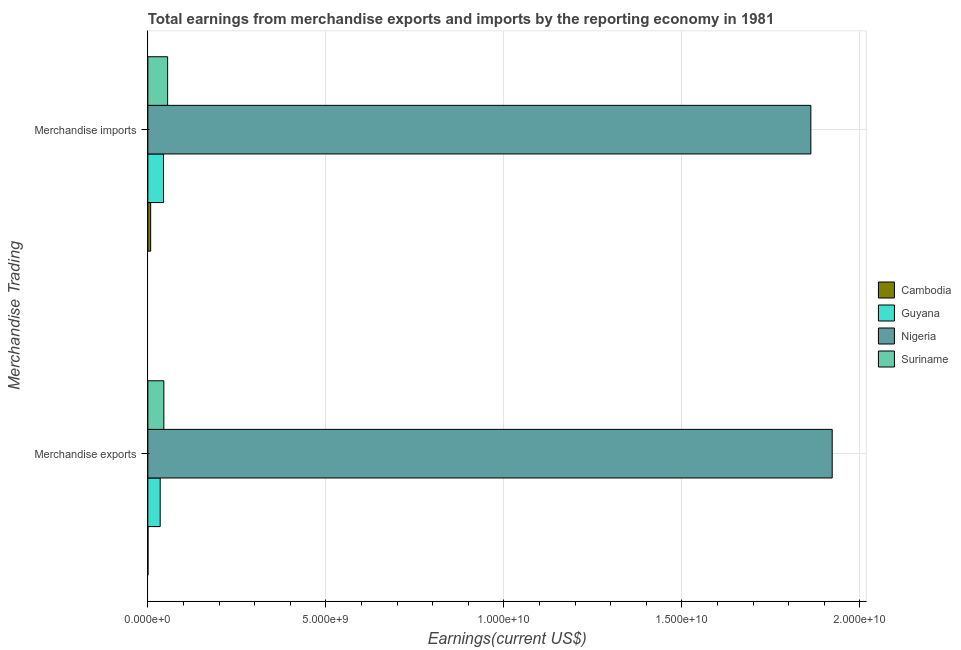How many bars are there on the 1st tick from the top?
Provide a short and direct response. 4. How many bars are there on the 2nd tick from the bottom?
Offer a very short reply. 4. What is the label of the 2nd group of bars from the top?
Offer a very short reply. Merchandise exports. What is the earnings from merchandise imports in Nigeria?
Your answer should be very brief. 1.86e+1. Across all countries, what is the maximum earnings from merchandise exports?
Offer a terse response. 1.92e+1. Across all countries, what is the minimum earnings from merchandise exports?
Keep it short and to the point. 2.37e+06. In which country was the earnings from merchandise exports maximum?
Your response must be concise. Nigeria. In which country was the earnings from merchandise imports minimum?
Offer a terse response. Cambodia. What is the total earnings from merchandise imports in the graph?
Make the answer very short. 1.97e+1. What is the difference between the earnings from merchandise imports in Nigeria and that in Guyana?
Your response must be concise. 1.82e+1. What is the difference between the earnings from merchandise imports in Nigeria and the earnings from merchandise exports in Guyana?
Keep it short and to the point. 1.83e+1. What is the average earnings from merchandise imports per country?
Offer a very short reply. 4.92e+09. What is the difference between the earnings from merchandise exports and earnings from merchandise imports in Nigeria?
Provide a short and direct response. 6.00e+08. In how many countries, is the earnings from merchandise imports greater than 18000000000 US$?
Offer a very short reply. 1. What is the ratio of the earnings from merchandise imports in Nigeria to that in Suriname?
Offer a very short reply. 33.57. In how many countries, is the earnings from merchandise exports greater than the average earnings from merchandise exports taken over all countries?
Make the answer very short. 1. What does the 3rd bar from the top in Merchandise exports represents?
Give a very brief answer. Guyana. What does the 1st bar from the bottom in Merchandise imports represents?
Provide a short and direct response. Cambodia. How many bars are there?
Provide a succinct answer. 8. Are all the bars in the graph horizontal?
Provide a succinct answer. Yes. Does the graph contain any zero values?
Ensure brevity in your answer.  No. How many legend labels are there?
Ensure brevity in your answer.  4. How are the legend labels stacked?
Offer a very short reply. Vertical. What is the title of the graph?
Offer a very short reply. Total earnings from merchandise exports and imports by the reporting economy in 1981. Does "Croatia" appear as one of the legend labels in the graph?
Give a very brief answer. No. What is the label or title of the X-axis?
Offer a terse response. Earnings(current US$). What is the label or title of the Y-axis?
Offer a terse response. Merchandise Trading. What is the Earnings(current US$) in Cambodia in Merchandise exports?
Your answer should be very brief. 2.37e+06. What is the Earnings(current US$) of Guyana in Merchandise exports?
Your answer should be compact. 3.46e+08. What is the Earnings(current US$) in Nigeria in Merchandise exports?
Your answer should be very brief. 1.92e+1. What is the Earnings(current US$) of Suriname in Merchandise exports?
Your response must be concise. 4.49e+08. What is the Earnings(current US$) of Cambodia in Merchandise imports?
Your answer should be very brief. 7.84e+07. What is the Earnings(current US$) in Guyana in Merchandise imports?
Your answer should be very brief. 4.40e+08. What is the Earnings(current US$) in Nigeria in Merchandise imports?
Ensure brevity in your answer.  1.86e+1. What is the Earnings(current US$) in Suriname in Merchandise imports?
Keep it short and to the point. 5.55e+08. Across all Merchandise Trading, what is the maximum Earnings(current US$) of Cambodia?
Provide a short and direct response. 7.84e+07. Across all Merchandise Trading, what is the maximum Earnings(current US$) in Guyana?
Your answer should be very brief. 4.40e+08. Across all Merchandise Trading, what is the maximum Earnings(current US$) of Nigeria?
Your answer should be very brief. 1.92e+1. Across all Merchandise Trading, what is the maximum Earnings(current US$) of Suriname?
Provide a short and direct response. 5.55e+08. Across all Merchandise Trading, what is the minimum Earnings(current US$) in Cambodia?
Your answer should be compact. 2.37e+06. Across all Merchandise Trading, what is the minimum Earnings(current US$) of Guyana?
Offer a very short reply. 3.46e+08. Across all Merchandise Trading, what is the minimum Earnings(current US$) in Nigeria?
Make the answer very short. 1.86e+1. Across all Merchandise Trading, what is the minimum Earnings(current US$) of Suriname?
Give a very brief answer. 4.49e+08. What is the total Earnings(current US$) of Cambodia in the graph?
Your answer should be very brief. 8.07e+07. What is the total Earnings(current US$) in Guyana in the graph?
Provide a succinct answer. 7.86e+08. What is the total Earnings(current US$) in Nigeria in the graph?
Offer a very short reply. 3.78e+1. What is the total Earnings(current US$) in Suriname in the graph?
Keep it short and to the point. 1.00e+09. What is the difference between the Earnings(current US$) of Cambodia in Merchandise exports and that in Merchandise imports?
Your response must be concise. -7.60e+07. What is the difference between the Earnings(current US$) of Guyana in Merchandise exports and that in Merchandise imports?
Your answer should be compact. -9.35e+07. What is the difference between the Earnings(current US$) in Nigeria in Merchandise exports and that in Merchandise imports?
Ensure brevity in your answer.  6.00e+08. What is the difference between the Earnings(current US$) of Suriname in Merchandise exports and that in Merchandise imports?
Provide a succinct answer. -1.05e+08. What is the difference between the Earnings(current US$) of Cambodia in Merchandise exports and the Earnings(current US$) of Guyana in Merchandise imports?
Provide a short and direct response. -4.37e+08. What is the difference between the Earnings(current US$) in Cambodia in Merchandise exports and the Earnings(current US$) in Nigeria in Merchandise imports?
Your answer should be compact. -1.86e+1. What is the difference between the Earnings(current US$) in Cambodia in Merchandise exports and the Earnings(current US$) in Suriname in Merchandise imports?
Your answer should be very brief. -5.52e+08. What is the difference between the Earnings(current US$) in Guyana in Merchandise exports and the Earnings(current US$) in Nigeria in Merchandise imports?
Ensure brevity in your answer.  -1.83e+1. What is the difference between the Earnings(current US$) of Guyana in Merchandise exports and the Earnings(current US$) of Suriname in Merchandise imports?
Your answer should be compact. -2.09e+08. What is the difference between the Earnings(current US$) of Nigeria in Merchandise exports and the Earnings(current US$) of Suriname in Merchandise imports?
Ensure brevity in your answer.  1.87e+1. What is the average Earnings(current US$) in Cambodia per Merchandise Trading?
Offer a terse response. 4.04e+07. What is the average Earnings(current US$) in Guyana per Merchandise Trading?
Your answer should be compact. 3.93e+08. What is the average Earnings(current US$) in Nigeria per Merchandise Trading?
Offer a very short reply. 1.89e+1. What is the average Earnings(current US$) in Suriname per Merchandise Trading?
Your answer should be compact. 5.02e+08. What is the difference between the Earnings(current US$) in Cambodia and Earnings(current US$) in Guyana in Merchandise exports?
Your response must be concise. -3.44e+08. What is the difference between the Earnings(current US$) in Cambodia and Earnings(current US$) in Nigeria in Merchandise exports?
Give a very brief answer. -1.92e+1. What is the difference between the Earnings(current US$) of Cambodia and Earnings(current US$) of Suriname in Merchandise exports?
Your answer should be compact. -4.47e+08. What is the difference between the Earnings(current US$) of Guyana and Earnings(current US$) of Nigeria in Merchandise exports?
Offer a terse response. -1.89e+1. What is the difference between the Earnings(current US$) of Guyana and Earnings(current US$) of Suriname in Merchandise exports?
Keep it short and to the point. -1.03e+08. What is the difference between the Earnings(current US$) of Nigeria and Earnings(current US$) of Suriname in Merchandise exports?
Provide a short and direct response. 1.88e+1. What is the difference between the Earnings(current US$) in Cambodia and Earnings(current US$) in Guyana in Merchandise imports?
Give a very brief answer. -3.61e+08. What is the difference between the Earnings(current US$) of Cambodia and Earnings(current US$) of Nigeria in Merchandise imports?
Your answer should be very brief. -1.85e+1. What is the difference between the Earnings(current US$) of Cambodia and Earnings(current US$) of Suriname in Merchandise imports?
Give a very brief answer. -4.76e+08. What is the difference between the Earnings(current US$) of Guyana and Earnings(current US$) of Nigeria in Merchandise imports?
Give a very brief answer. -1.82e+1. What is the difference between the Earnings(current US$) in Guyana and Earnings(current US$) in Suriname in Merchandise imports?
Give a very brief answer. -1.15e+08. What is the difference between the Earnings(current US$) of Nigeria and Earnings(current US$) of Suriname in Merchandise imports?
Provide a succinct answer. 1.81e+1. What is the ratio of the Earnings(current US$) in Cambodia in Merchandise exports to that in Merchandise imports?
Offer a terse response. 0.03. What is the ratio of the Earnings(current US$) in Guyana in Merchandise exports to that in Merchandise imports?
Your response must be concise. 0.79. What is the ratio of the Earnings(current US$) of Nigeria in Merchandise exports to that in Merchandise imports?
Your answer should be compact. 1.03. What is the ratio of the Earnings(current US$) in Suriname in Merchandise exports to that in Merchandise imports?
Keep it short and to the point. 0.81. What is the difference between the highest and the second highest Earnings(current US$) of Cambodia?
Your answer should be very brief. 7.60e+07. What is the difference between the highest and the second highest Earnings(current US$) in Guyana?
Offer a terse response. 9.35e+07. What is the difference between the highest and the second highest Earnings(current US$) of Nigeria?
Your answer should be very brief. 6.00e+08. What is the difference between the highest and the second highest Earnings(current US$) in Suriname?
Make the answer very short. 1.05e+08. What is the difference between the highest and the lowest Earnings(current US$) in Cambodia?
Provide a succinct answer. 7.60e+07. What is the difference between the highest and the lowest Earnings(current US$) of Guyana?
Your response must be concise. 9.35e+07. What is the difference between the highest and the lowest Earnings(current US$) in Nigeria?
Give a very brief answer. 6.00e+08. What is the difference between the highest and the lowest Earnings(current US$) of Suriname?
Your response must be concise. 1.05e+08. 